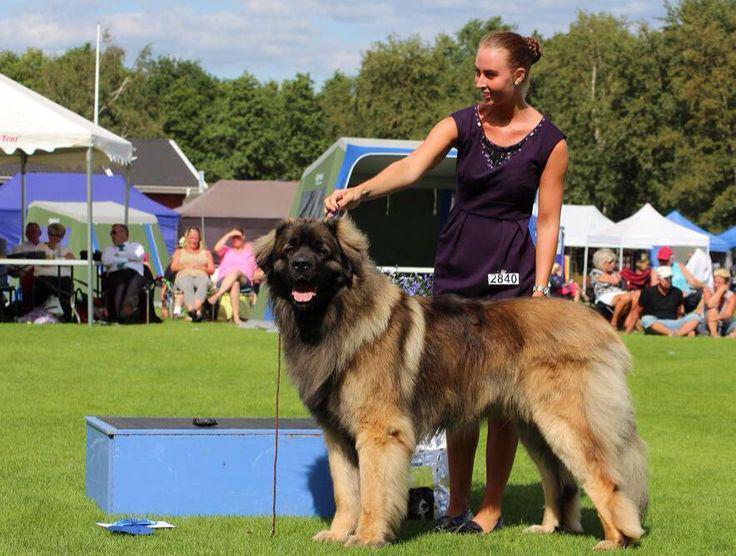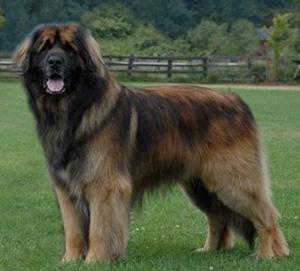The first image is the image on the left, the second image is the image on the right. Assess this claim about the two images: "There is one adult human in the image on the left". Correct or not? Answer yes or no. Yes. The first image is the image on the left, the second image is the image on the right. Evaluate the accuracy of this statement regarding the images: "Only one image is of a dog with no people present.". Is it true? Answer yes or no. Yes. 